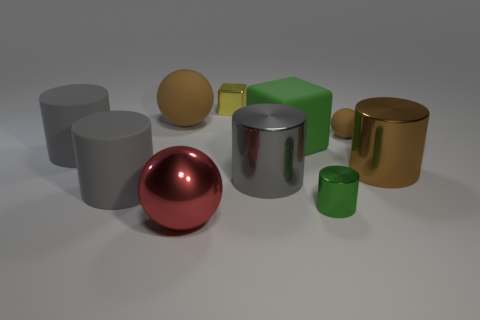How many gray cylinders must be subtracted to get 1 gray cylinders? 2 Subtract all tiny cylinders. How many cylinders are left? 4 Subtract all cyan spheres. How many gray cylinders are left? 3 Subtract all yellow blocks. How many blocks are left? 1 Subtract 1 balls. How many balls are left? 2 Add 5 green rubber blocks. How many green rubber blocks are left? 6 Add 7 tiny purple rubber cylinders. How many tiny purple rubber cylinders exist? 7 Subtract 0 yellow spheres. How many objects are left? 10 Subtract all blocks. How many objects are left? 8 Subtract all cyan spheres. Subtract all gray blocks. How many spheres are left? 3 